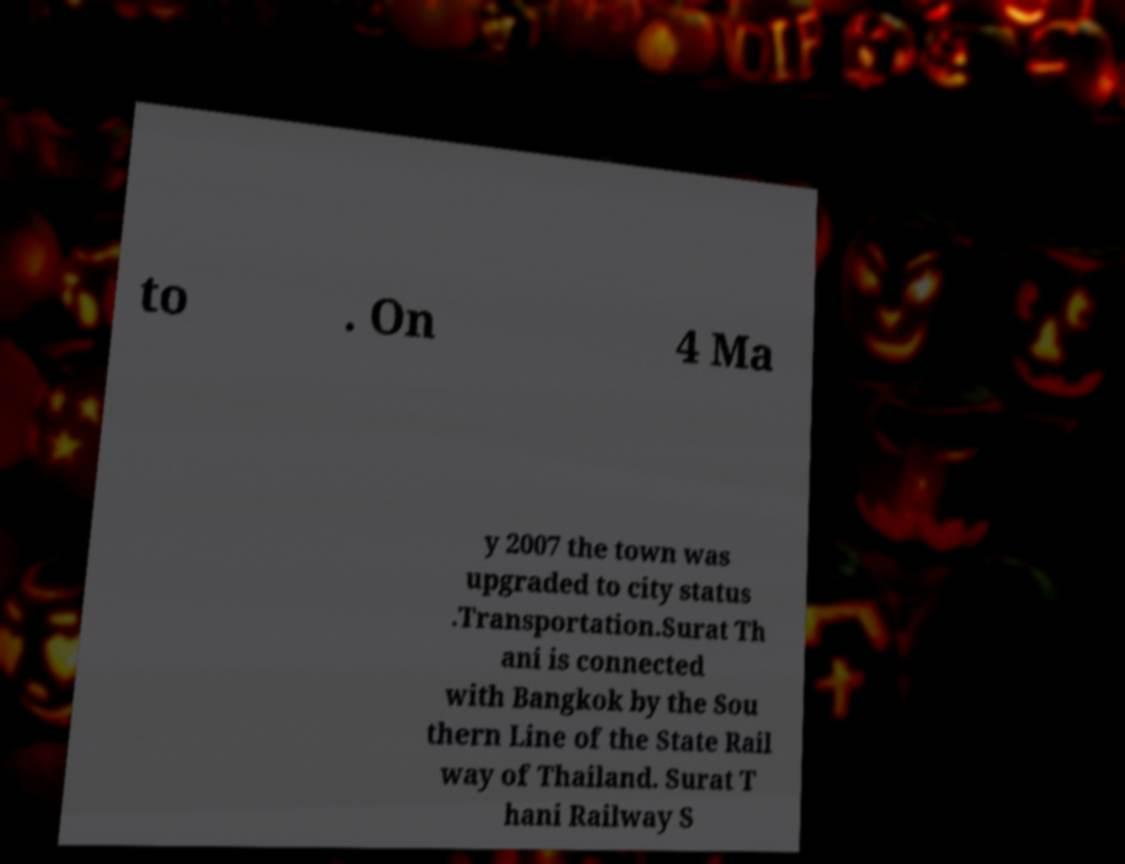I need the written content from this picture converted into text. Can you do that? to . On 4 Ma y 2007 the town was upgraded to city status .Transportation.Surat Th ani is connected with Bangkok by the Sou thern Line of the State Rail way of Thailand. Surat T hani Railway S 